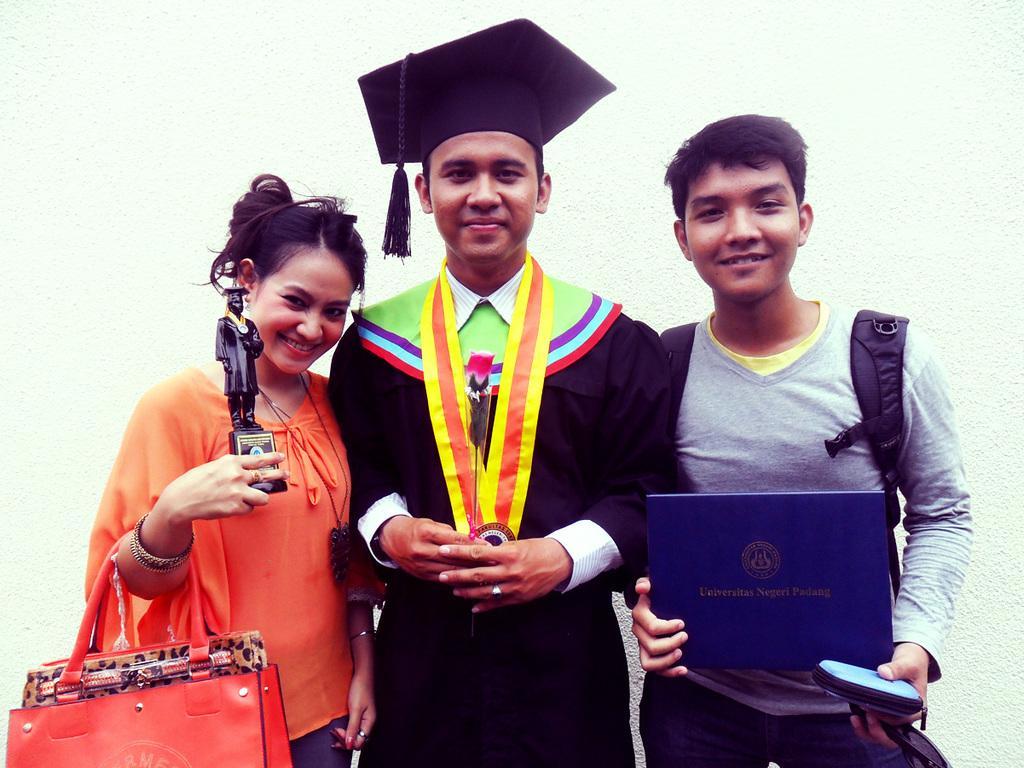How would you summarize this image in a sentence or two? In the image we can see three persons were standing and they were laughing. And on the left we can see woman holding handbag. And back we can see wall. 